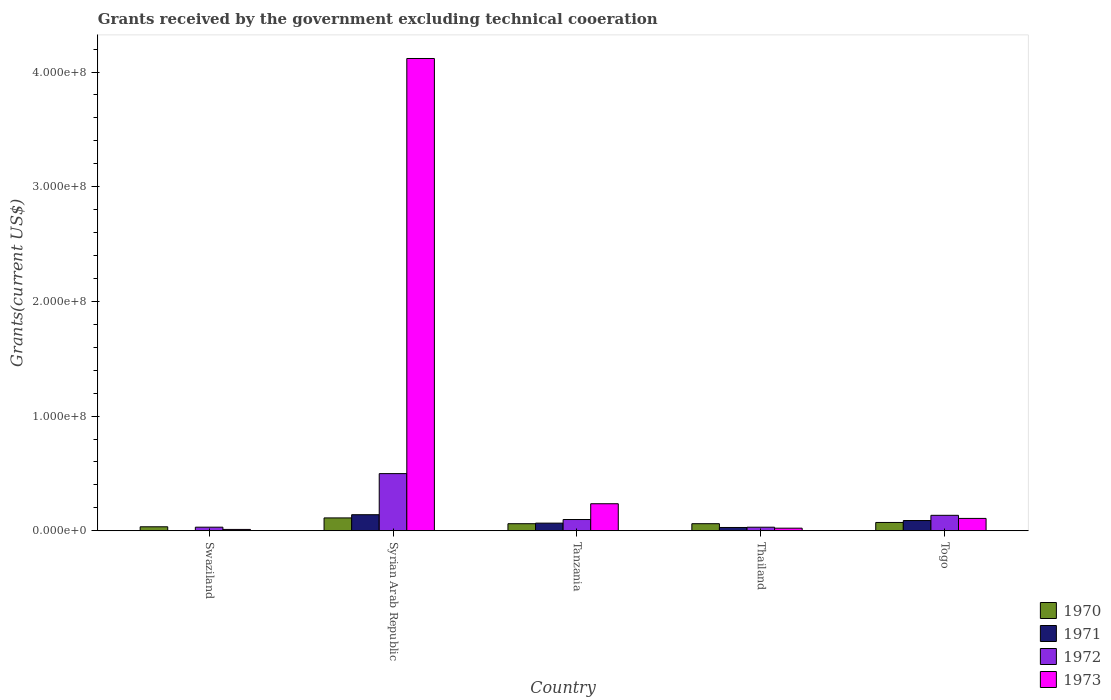How many different coloured bars are there?
Provide a succinct answer. 4. How many groups of bars are there?
Provide a succinct answer. 5. Are the number of bars per tick equal to the number of legend labels?
Your response must be concise. No. How many bars are there on the 4th tick from the left?
Your response must be concise. 4. What is the label of the 3rd group of bars from the left?
Offer a very short reply. Tanzania. What is the total grants received by the government in 1971 in Tanzania?
Offer a very short reply. 6.68e+06. Across all countries, what is the maximum total grants received by the government in 1973?
Your response must be concise. 4.12e+08. Across all countries, what is the minimum total grants received by the government in 1970?
Keep it short and to the point. 3.49e+06. In which country was the total grants received by the government in 1973 maximum?
Keep it short and to the point. Syrian Arab Republic. What is the total total grants received by the government in 1971 in the graph?
Provide a short and direct response. 3.25e+07. What is the difference between the total grants received by the government in 1972 in Tanzania and that in Thailand?
Ensure brevity in your answer.  6.70e+06. What is the difference between the total grants received by the government in 1971 in Syrian Arab Republic and the total grants received by the government in 1973 in Tanzania?
Provide a succinct answer. -9.57e+06. What is the average total grants received by the government in 1972 per country?
Make the answer very short. 1.59e+07. What is the difference between the total grants received by the government of/in 1973 and total grants received by the government of/in 1971 in Tanzania?
Offer a terse response. 1.69e+07. In how many countries, is the total grants received by the government in 1973 greater than 120000000 US$?
Make the answer very short. 1. What is the ratio of the total grants received by the government in 1971 in Syrian Arab Republic to that in Tanzania?
Your answer should be compact. 2.1. Is the difference between the total grants received by the government in 1973 in Tanzania and Thailand greater than the difference between the total grants received by the government in 1971 in Tanzania and Thailand?
Make the answer very short. Yes. What is the difference between the highest and the second highest total grants received by the government in 1970?
Your answer should be very brief. 3.97e+06. What is the difference between the highest and the lowest total grants received by the government in 1972?
Give a very brief answer. 4.67e+07. Is the sum of the total grants received by the government in 1973 in Syrian Arab Republic and Tanzania greater than the maximum total grants received by the government in 1970 across all countries?
Offer a very short reply. Yes. Is it the case that in every country, the sum of the total grants received by the government in 1973 and total grants received by the government in 1971 is greater than the sum of total grants received by the government in 1972 and total grants received by the government in 1970?
Your response must be concise. No. Is it the case that in every country, the sum of the total grants received by the government in 1972 and total grants received by the government in 1973 is greater than the total grants received by the government in 1971?
Keep it short and to the point. Yes. How many bars are there?
Make the answer very short. 19. How many countries are there in the graph?
Your answer should be compact. 5. What is the difference between two consecutive major ticks on the Y-axis?
Provide a succinct answer. 1.00e+08. Does the graph contain any zero values?
Give a very brief answer. Yes. Does the graph contain grids?
Provide a succinct answer. No. How are the legend labels stacked?
Make the answer very short. Vertical. What is the title of the graph?
Offer a very short reply. Grants received by the government excluding technical cooeration. What is the label or title of the Y-axis?
Make the answer very short. Grants(current US$). What is the Grants(current US$) of 1970 in Swaziland?
Your response must be concise. 3.49e+06. What is the Grants(current US$) of 1971 in Swaziland?
Your answer should be very brief. 0. What is the Grants(current US$) of 1972 in Swaziland?
Provide a succinct answer. 3.14e+06. What is the Grants(current US$) in 1973 in Swaziland?
Ensure brevity in your answer.  1.18e+06. What is the Grants(current US$) of 1970 in Syrian Arab Republic?
Offer a terse response. 1.12e+07. What is the Grants(current US$) of 1971 in Syrian Arab Republic?
Your answer should be very brief. 1.40e+07. What is the Grants(current US$) in 1972 in Syrian Arab Republic?
Your answer should be compact. 4.98e+07. What is the Grants(current US$) in 1973 in Syrian Arab Republic?
Ensure brevity in your answer.  4.12e+08. What is the Grants(current US$) of 1970 in Tanzania?
Give a very brief answer. 6.17e+06. What is the Grants(current US$) in 1971 in Tanzania?
Make the answer very short. 6.68e+06. What is the Grants(current US$) of 1972 in Tanzania?
Provide a short and direct response. 9.82e+06. What is the Grants(current US$) in 1973 in Tanzania?
Make the answer very short. 2.36e+07. What is the Grants(current US$) of 1970 in Thailand?
Provide a succinct answer. 6.18e+06. What is the Grants(current US$) in 1971 in Thailand?
Provide a succinct answer. 2.88e+06. What is the Grants(current US$) in 1972 in Thailand?
Offer a terse response. 3.12e+06. What is the Grants(current US$) in 1973 in Thailand?
Keep it short and to the point. 2.27e+06. What is the Grants(current US$) of 1970 in Togo?
Offer a very short reply. 7.26e+06. What is the Grants(current US$) of 1971 in Togo?
Provide a short and direct response. 8.93e+06. What is the Grants(current US$) of 1972 in Togo?
Provide a short and direct response. 1.35e+07. What is the Grants(current US$) in 1973 in Togo?
Give a very brief answer. 1.08e+07. Across all countries, what is the maximum Grants(current US$) in 1970?
Ensure brevity in your answer.  1.12e+07. Across all countries, what is the maximum Grants(current US$) of 1971?
Offer a very short reply. 1.40e+07. Across all countries, what is the maximum Grants(current US$) of 1972?
Your answer should be compact. 4.98e+07. Across all countries, what is the maximum Grants(current US$) of 1973?
Give a very brief answer. 4.12e+08. Across all countries, what is the minimum Grants(current US$) of 1970?
Provide a short and direct response. 3.49e+06. Across all countries, what is the minimum Grants(current US$) of 1971?
Provide a short and direct response. 0. Across all countries, what is the minimum Grants(current US$) of 1972?
Offer a terse response. 3.12e+06. Across all countries, what is the minimum Grants(current US$) in 1973?
Give a very brief answer. 1.18e+06. What is the total Grants(current US$) in 1970 in the graph?
Ensure brevity in your answer.  3.43e+07. What is the total Grants(current US$) in 1971 in the graph?
Offer a terse response. 3.25e+07. What is the total Grants(current US$) of 1972 in the graph?
Offer a very short reply. 7.94e+07. What is the total Grants(current US$) of 1973 in the graph?
Offer a terse response. 4.50e+08. What is the difference between the Grants(current US$) of 1970 in Swaziland and that in Syrian Arab Republic?
Provide a succinct answer. -7.74e+06. What is the difference between the Grants(current US$) in 1972 in Swaziland and that in Syrian Arab Republic?
Your answer should be compact. -4.67e+07. What is the difference between the Grants(current US$) of 1973 in Swaziland and that in Syrian Arab Republic?
Keep it short and to the point. -4.11e+08. What is the difference between the Grants(current US$) in 1970 in Swaziland and that in Tanzania?
Provide a succinct answer. -2.68e+06. What is the difference between the Grants(current US$) of 1972 in Swaziland and that in Tanzania?
Provide a succinct answer. -6.68e+06. What is the difference between the Grants(current US$) in 1973 in Swaziland and that in Tanzania?
Ensure brevity in your answer.  -2.24e+07. What is the difference between the Grants(current US$) of 1970 in Swaziland and that in Thailand?
Ensure brevity in your answer.  -2.69e+06. What is the difference between the Grants(current US$) of 1973 in Swaziland and that in Thailand?
Keep it short and to the point. -1.09e+06. What is the difference between the Grants(current US$) in 1970 in Swaziland and that in Togo?
Make the answer very short. -3.77e+06. What is the difference between the Grants(current US$) of 1972 in Swaziland and that in Togo?
Offer a terse response. -1.03e+07. What is the difference between the Grants(current US$) in 1973 in Swaziland and that in Togo?
Make the answer very short. -9.61e+06. What is the difference between the Grants(current US$) of 1970 in Syrian Arab Republic and that in Tanzania?
Give a very brief answer. 5.06e+06. What is the difference between the Grants(current US$) in 1971 in Syrian Arab Republic and that in Tanzania?
Keep it short and to the point. 7.33e+06. What is the difference between the Grants(current US$) in 1972 in Syrian Arab Republic and that in Tanzania?
Offer a very short reply. 4.00e+07. What is the difference between the Grants(current US$) of 1973 in Syrian Arab Republic and that in Tanzania?
Offer a very short reply. 3.88e+08. What is the difference between the Grants(current US$) of 1970 in Syrian Arab Republic and that in Thailand?
Your answer should be compact. 5.05e+06. What is the difference between the Grants(current US$) of 1971 in Syrian Arab Republic and that in Thailand?
Offer a terse response. 1.11e+07. What is the difference between the Grants(current US$) of 1972 in Syrian Arab Republic and that in Thailand?
Keep it short and to the point. 4.67e+07. What is the difference between the Grants(current US$) in 1973 in Syrian Arab Republic and that in Thailand?
Give a very brief answer. 4.10e+08. What is the difference between the Grants(current US$) in 1970 in Syrian Arab Republic and that in Togo?
Your answer should be compact. 3.97e+06. What is the difference between the Grants(current US$) in 1971 in Syrian Arab Republic and that in Togo?
Your answer should be compact. 5.08e+06. What is the difference between the Grants(current US$) of 1972 in Syrian Arab Republic and that in Togo?
Give a very brief answer. 3.64e+07. What is the difference between the Grants(current US$) of 1973 in Syrian Arab Republic and that in Togo?
Give a very brief answer. 4.01e+08. What is the difference between the Grants(current US$) of 1971 in Tanzania and that in Thailand?
Your answer should be compact. 3.80e+06. What is the difference between the Grants(current US$) of 1972 in Tanzania and that in Thailand?
Provide a succinct answer. 6.70e+06. What is the difference between the Grants(current US$) of 1973 in Tanzania and that in Thailand?
Your response must be concise. 2.13e+07. What is the difference between the Grants(current US$) in 1970 in Tanzania and that in Togo?
Offer a terse response. -1.09e+06. What is the difference between the Grants(current US$) in 1971 in Tanzania and that in Togo?
Provide a succinct answer. -2.25e+06. What is the difference between the Grants(current US$) of 1972 in Tanzania and that in Togo?
Your answer should be very brief. -3.66e+06. What is the difference between the Grants(current US$) of 1973 in Tanzania and that in Togo?
Give a very brief answer. 1.28e+07. What is the difference between the Grants(current US$) in 1970 in Thailand and that in Togo?
Provide a succinct answer. -1.08e+06. What is the difference between the Grants(current US$) in 1971 in Thailand and that in Togo?
Your answer should be very brief. -6.05e+06. What is the difference between the Grants(current US$) of 1972 in Thailand and that in Togo?
Provide a short and direct response. -1.04e+07. What is the difference between the Grants(current US$) of 1973 in Thailand and that in Togo?
Offer a very short reply. -8.52e+06. What is the difference between the Grants(current US$) in 1970 in Swaziland and the Grants(current US$) in 1971 in Syrian Arab Republic?
Give a very brief answer. -1.05e+07. What is the difference between the Grants(current US$) of 1970 in Swaziland and the Grants(current US$) of 1972 in Syrian Arab Republic?
Provide a short and direct response. -4.64e+07. What is the difference between the Grants(current US$) in 1970 in Swaziland and the Grants(current US$) in 1973 in Syrian Arab Republic?
Make the answer very short. -4.08e+08. What is the difference between the Grants(current US$) in 1972 in Swaziland and the Grants(current US$) in 1973 in Syrian Arab Republic?
Keep it short and to the point. -4.09e+08. What is the difference between the Grants(current US$) in 1970 in Swaziland and the Grants(current US$) in 1971 in Tanzania?
Your answer should be very brief. -3.19e+06. What is the difference between the Grants(current US$) of 1970 in Swaziland and the Grants(current US$) of 1972 in Tanzania?
Offer a terse response. -6.33e+06. What is the difference between the Grants(current US$) of 1970 in Swaziland and the Grants(current US$) of 1973 in Tanzania?
Your answer should be very brief. -2.01e+07. What is the difference between the Grants(current US$) of 1972 in Swaziland and the Grants(current US$) of 1973 in Tanzania?
Provide a succinct answer. -2.04e+07. What is the difference between the Grants(current US$) of 1970 in Swaziland and the Grants(current US$) of 1973 in Thailand?
Your answer should be very brief. 1.22e+06. What is the difference between the Grants(current US$) of 1972 in Swaziland and the Grants(current US$) of 1973 in Thailand?
Your answer should be compact. 8.70e+05. What is the difference between the Grants(current US$) of 1970 in Swaziland and the Grants(current US$) of 1971 in Togo?
Make the answer very short. -5.44e+06. What is the difference between the Grants(current US$) of 1970 in Swaziland and the Grants(current US$) of 1972 in Togo?
Provide a succinct answer. -9.99e+06. What is the difference between the Grants(current US$) in 1970 in Swaziland and the Grants(current US$) in 1973 in Togo?
Provide a succinct answer. -7.30e+06. What is the difference between the Grants(current US$) in 1972 in Swaziland and the Grants(current US$) in 1973 in Togo?
Offer a very short reply. -7.65e+06. What is the difference between the Grants(current US$) in 1970 in Syrian Arab Republic and the Grants(current US$) in 1971 in Tanzania?
Give a very brief answer. 4.55e+06. What is the difference between the Grants(current US$) in 1970 in Syrian Arab Republic and the Grants(current US$) in 1972 in Tanzania?
Provide a short and direct response. 1.41e+06. What is the difference between the Grants(current US$) in 1970 in Syrian Arab Republic and the Grants(current US$) in 1973 in Tanzania?
Make the answer very short. -1.24e+07. What is the difference between the Grants(current US$) of 1971 in Syrian Arab Republic and the Grants(current US$) of 1972 in Tanzania?
Make the answer very short. 4.19e+06. What is the difference between the Grants(current US$) in 1971 in Syrian Arab Republic and the Grants(current US$) in 1973 in Tanzania?
Provide a short and direct response. -9.57e+06. What is the difference between the Grants(current US$) of 1972 in Syrian Arab Republic and the Grants(current US$) of 1973 in Tanzania?
Make the answer very short. 2.63e+07. What is the difference between the Grants(current US$) of 1970 in Syrian Arab Republic and the Grants(current US$) of 1971 in Thailand?
Your answer should be compact. 8.35e+06. What is the difference between the Grants(current US$) of 1970 in Syrian Arab Republic and the Grants(current US$) of 1972 in Thailand?
Your answer should be very brief. 8.11e+06. What is the difference between the Grants(current US$) in 1970 in Syrian Arab Republic and the Grants(current US$) in 1973 in Thailand?
Your response must be concise. 8.96e+06. What is the difference between the Grants(current US$) in 1971 in Syrian Arab Republic and the Grants(current US$) in 1972 in Thailand?
Your response must be concise. 1.09e+07. What is the difference between the Grants(current US$) of 1971 in Syrian Arab Republic and the Grants(current US$) of 1973 in Thailand?
Make the answer very short. 1.17e+07. What is the difference between the Grants(current US$) of 1972 in Syrian Arab Republic and the Grants(current US$) of 1973 in Thailand?
Provide a short and direct response. 4.76e+07. What is the difference between the Grants(current US$) of 1970 in Syrian Arab Republic and the Grants(current US$) of 1971 in Togo?
Give a very brief answer. 2.30e+06. What is the difference between the Grants(current US$) of 1970 in Syrian Arab Republic and the Grants(current US$) of 1972 in Togo?
Offer a terse response. -2.25e+06. What is the difference between the Grants(current US$) in 1970 in Syrian Arab Republic and the Grants(current US$) in 1973 in Togo?
Make the answer very short. 4.40e+05. What is the difference between the Grants(current US$) in 1971 in Syrian Arab Republic and the Grants(current US$) in 1972 in Togo?
Your answer should be very brief. 5.30e+05. What is the difference between the Grants(current US$) in 1971 in Syrian Arab Republic and the Grants(current US$) in 1973 in Togo?
Provide a short and direct response. 3.22e+06. What is the difference between the Grants(current US$) in 1972 in Syrian Arab Republic and the Grants(current US$) in 1973 in Togo?
Ensure brevity in your answer.  3.91e+07. What is the difference between the Grants(current US$) in 1970 in Tanzania and the Grants(current US$) in 1971 in Thailand?
Your response must be concise. 3.29e+06. What is the difference between the Grants(current US$) in 1970 in Tanzania and the Grants(current US$) in 1972 in Thailand?
Make the answer very short. 3.05e+06. What is the difference between the Grants(current US$) of 1970 in Tanzania and the Grants(current US$) of 1973 in Thailand?
Offer a terse response. 3.90e+06. What is the difference between the Grants(current US$) in 1971 in Tanzania and the Grants(current US$) in 1972 in Thailand?
Keep it short and to the point. 3.56e+06. What is the difference between the Grants(current US$) of 1971 in Tanzania and the Grants(current US$) of 1973 in Thailand?
Offer a very short reply. 4.41e+06. What is the difference between the Grants(current US$) of 1972 in Tanzania and the Grants(current US$) of 1973 in Thailand?
Offer a terse response. 7.55e+06. What is the difference between the Grants(current US$) in 1970 in Tanzania and the Grants(current US$) in 1971 in Togo?
Your answer should be very brief. -2.76e+06. What is the difference between the Grants(current US$) of 1970 in Tanzania and the Grants(current US$) of 1972 in Togo?
Provide a succinct answer. -7.31e+06. What is the difference between the Grants(current US$) in 1970 in Tanzania and the Grants(current US$) in 1973 in Togo?
Your answer should be very brief. -4.62e+06. What is the difference between the Grants(current US$) in 1971 in Tanzania and the Grants(current US$) in 1972 in Togo?
Make the answer very short. -6.80e+06. What is the difference between the Grants(current US$) in 1971 in Tanzania and the Grants(current US$) in 1973 in Togo?
Your response must be concise. -4.11e+06. What is the difference between the Grants(current US$) in 1972 in Tanzania and the Grants(current US$) in 1973 in Togo?
Your answer should be compact. -9.70e+05. What is the difference between the Grants(current US$) in 1970 in Thailand and the Grants(current US$) in 1971 in Togo?
Provide a succinct answer. -2.75e+06. What is the difference between the Grants(current US$) of 1970 in Thailand and the Grants(current US$) of 1972 in Togo?
Provide a succinct answer. -7.30e+06. What is the difference between the Grants(current US$) in 1970 in Thailand and the Grants(current US$) in 1973 in Togo?
Your response must be concise. -4.61e+06. What is the difference between the Grants(current US$) of 1971 in Thailand and the Grants(current US$) of 1972 in Togo?
Provide a short and direct response. -1.06e+07. What is the difference between the Grants(current US$) of 1971 in Thailand and the Grants(current US$) of 1973 in Togo?
Your response must be concise. -7.91e+06. What is the difference between the Grants(current US$) in 1972 in Thailand and the Grants(current US$) in 1973 in Togo?
Your answer should be compact. -7.67e+06. What is the average Grants(current US$) in 1970 per country?
Your response must be concise. 6.87e+06. What is the average Grants(current US$) of 1971 per country?
Your answer should be very brief. 6.50e+06. What is the average Grants(current US$) in 1972 per country?
Offer a terse response. 1.59e+07. What is the average Grants(current US$) in 1973 per country?
Make the answer very short. 8.99e+07. What is the difference between the Grants(current US$) of 1970 and Grants(current US$) of 1973 in Swaziland?
Provide a succinct answer. 2.31e+06. What is the difference between the Grants(current US$) of 1972 and Grants(current US$) of 1973 in Swaziland?
Your answer should be compact. 1.96e+06. What is the difference between the Grants(current US$) of 1970 and Grants(current US$) of 1971 in Syrian Arab Republic?
Offer a terse response. -2.78e+06. What is the difference between the Grants(current US$) of 1970 and Grants(current US$) of 1972 in Syrian Arab Republic?
Make the answer very short. -3.86e+07. What is the difference between the Grants(current US$) of 1970 and Grants(current US$) of 1973 in Syrian Arab Republic?
Ensure brevity in your answer.  -4.01e+08. What is the difference between the Grants(current US$) of 1971 and Grants(current US$) of 1972 in Syrian Arab Republic?
Ensure brevity in your answer.  -3.58e+07. What is the difference between the Grants(current US$) in 1971 and Grants(current US$) in 1973 in Syrian Arab Republic?
Make the answer very short. -3.98e+08. What is the difference between the Grants(current US$) in 1972 and Grants(current US$) in 1973 in Syrian Arab Republic?
Your response must be concise. -3.62e+08. What is the difference between the Grants(current US$) in 1970 and Grants(current US$) in 1971 in Tanzania?
Provide a short and direct response. -5.10e+05. What is the difference between the Grants(current US$) of 1970 and Grants(current US$) of 1972 in Tanzania?
Offer a very short reply. -3.65e+06. What is the difference between the Grants(current US$) of 1970 and Grants(current US$) of 1973 in Tanzania?
Your answer should be compact. -1.74e+07. What is the difference between the Grants(current US$) in 1971 and Grants(current US$) in 1972 in Tanzania?
Offer a terse response. -3.14e+06. What is the difference between the Grants(current US$) in 1971 and Grants(current US$) in 1973 in Tanzania?
Provide a succinct answer. -1.69e+07. What is the difference between the Grants(current US$) in 1972 and Grants(current US$) in 1973 in Tanzania?
Give a very brief answer. -1.38e+07. What is the difference between the Grants(current US$) in 1970 and Grants(current US$) in 1971 in Thailand?
Give a very brief answer. 3.30e+06. What is the difference between the Grants(current US$) of 1970 and Grants(current US$) of 1972 in Thailand?
Keep it short and to the point. 3.06e+06. What is the difference between the Grants(current US$) of 1970 and Grants(current US$) of 1973 in Thailand?
Make the answer very short. 3.91e+06. What is the difference between the Grants(current US$) of 1972 and Grants(current US$) of 1973 in Thailand?
Provide a succinct answer. 8.50e+05. What is the difference between the Grants(current US$) of 1970 and Grants(current US$) of 1971 in Togo?
Provide a short and direct response. -1.67e+06. What is the difference between the Grants(current US$) of 1970 and Grants(current US$) of 1972 in Togo?
Provide a short and direct response. -6.22e+06. What is the difference between the Grants(current US$) in 1970 and Grants(current US$) in 1973 in Togo?
Keep it short and to the point. -3.53e+06. What is the difference between the Grants(current US$) in 1971 and Grants(current US$) in 1972 in Togo?
Your response must be concise. -4.55e+06. What is the difference between the Grants(current US$) of 1971 and Grants(current US$) of 1973 in Togo?
Keep it short and to the point. -1.86e+06. What is the difference between the Grants(current US$) of 1972 and Grants(current US$) of 1973 in Togo?
Keep it short and to the point. 2.69e+06. What is the ratio of the Grants(current US$) of 1970 in Swaziland to that in Syrian Arab Republic?
Offer a terse response. 0.31. What is the ratio of the Grants(current US$) of 1972 in Swaziland to that in Syrian Arab Republic?
Offer a terse response. 0.06. What is the ratio of the Grants(current US$) in 1973 in Swaziland to that in Syrian Arab Republic?
Keep it short and to the point. 0. What is the ratio of the Grants(current US$) of 1970 in Swaziland to that in Tanzania?
Provide a short and direct response. 0.57. What is the ratio of the Grants(current US$) of 1972 in Swaziland to that in Tanzania?
Ensure brevity in your answer.  0.32. What is the ratio of the Grants(current US$) in 1973 in Swaziland to that in Tanzania?
Keep it short and to the point. 0.05. What is the ratio of the Grants(current US$) in 1970 in Swaziland to that in Thailand?
Give a very brief answer. 0.56. What is the ratio of the Grants(current US$) in 1972 in Swaziland to that in Thailand?
Make the answer very short. 1.01. What is the ratio of the Grants(current US$) in 1973 in Swaziland to that in Thailand?
Give a very brief answer. 0.52. What is the ratio of the Grants(current US$) in 1970 in Swaziland to that in Togo?
Provide a short and direct response. 0.48. What is the ratio of the Grants(current US$) in 1972 in Swaziland to that in Togo?
Your answer should be compact. 0.23. What is the ratio of the Grants(current US$) in 1973 in Swaziland to that in Togo?
Provide a short and direct response. 0.11. What is the ratio of the Grants(current US$) in 1970 in Syrian Arab Republic to that in Tanzania?
Offer a very short reply. 1.82. What is the ratio of the Grants(current US$) of 1971 in Syrian Arab Republic to that in Tanzania?
Offer a terse response. 2.1. What is the ratio of the Grants(current US$) in 1972 in Syrian Arab Republic to that in Tanzania?
Offer a very short reply. 5.08. What is the ratio of the Grants(current US$) of 1973 in Syrian Arab Republic to that in Tanzania?
Give a very brief answer. 17.46. What is the ratio of the Grants(current US$) in 1970 in Syrian Arab Republic to that in Thailand?
Offer a terse response. 1.82. What is the ratio of the Grants(current US$) in 1971 in Syrian Arab Republic to that in Thailand?
Offer a terse response. 4.86. What is the ratio of the Grants(current US$) of 1972 in Syrian Arab Republic to that in Thailand?
Your answer should be very brief. 15.98. What is the ratio of the Grants(current US$) in 1973 in Syrian Arab Republic to that in Thailand?
Your response must be concise. 181.41. What is the ratio of the Grants(current US$) of 1970 in Syrian Arab Republic to that in Togo?
Your response must be concise. 1.55. What is the ratio of the Grants(current US$) in 1971 in Syrian Arab Republic to that in Togo?
Your answer should be compact. 1.57. What is the ratio of the Grants(current US$) in 1972 in Syrian Arab Republic to that in Togo?
Make the answer very short. 3.7. What is the ratio of the Grants(current US$) of 1973 in Syrian Arab Republic to that in Togo?
Offer a very short reply. 38.16. What is the ratio of the Grants(current US$) in 1971 in Tanzania to that in Thailand?
Offer a very short reply. 2.32. What is the ratio of the Grants(current US$) of 1972 in Tanzania to that in Thailand?
Make the answer very short. 3.15. What is the ratio of the Grants(current US$) of 1973 in Tanzania to that in Thailand?
Keep it short and to the point. 10.39. What is the ratio of the Grants(current US$) of 1970 in Tanzania to that in Togo?
Provide a succinct answer. 0.85. What is the ratio of the Grants(current US$) of 1971 in Tanzania to that in Togo?
Give a very brief answer. 0.75. What is the ratio of the Grants(current US$) of 1972 in Tanzania to that in Togo?
Ensure brevity in your answer.  0.73. What is the ratio of the Grants(current US$) in 1973 in Tanzania to that in Togo?
Give a very brief answer. 2.19. What is the ratio of the Grants(current US$) of 1970 in Thailand to that in Togo?
Ensure brevity in your answer.  0.85. What is the ratio of the Grants(current US$) in 1971 in Thailand to that in Togo?
Your response must be concise. 0.32. What is the ratio of the Grants(current US$) of 1972 in Thailand to that in Togo?
Your response must be concise. 0.23. What is the ratio of the Grants(current US$) in 1973 in Thailand to that in Togo?
Your response must be concise. 0.21. What is the difference between the highest and the second highest Grants(current US$) of 1970?
Give a very brief answer. 3.97e+06. What is the difference between the highest and the second highest Grants(current US$) of 1971?
Provide a succinct answer. 5.08e+06. What is the difference between the highest and the second highest Grants(current US$) in 1972?
Ensure brevity in your answer.  3.64e+07. What is the difference between the highest and the second highest Grants(current US$) of 1973?
Offer a very short reply. 3.88e+08. What is the difference between the highest and the lowest Grants(current US$) of 1970?
Your response must be concise. 7.74e+06. What is the difference between the highest and the lowest Grants(current US$) in 1971?
Your answer should be compact. 1.40e+07. What is the difference between the highest and the lowest Grants(current US$) of 1972?
Provide a short and direct response. 4.67e+07. What is the difference between the highest and the lowest Grants(current US$) of 1973?
Ensure brevity in your answer.  4.11e+08. 